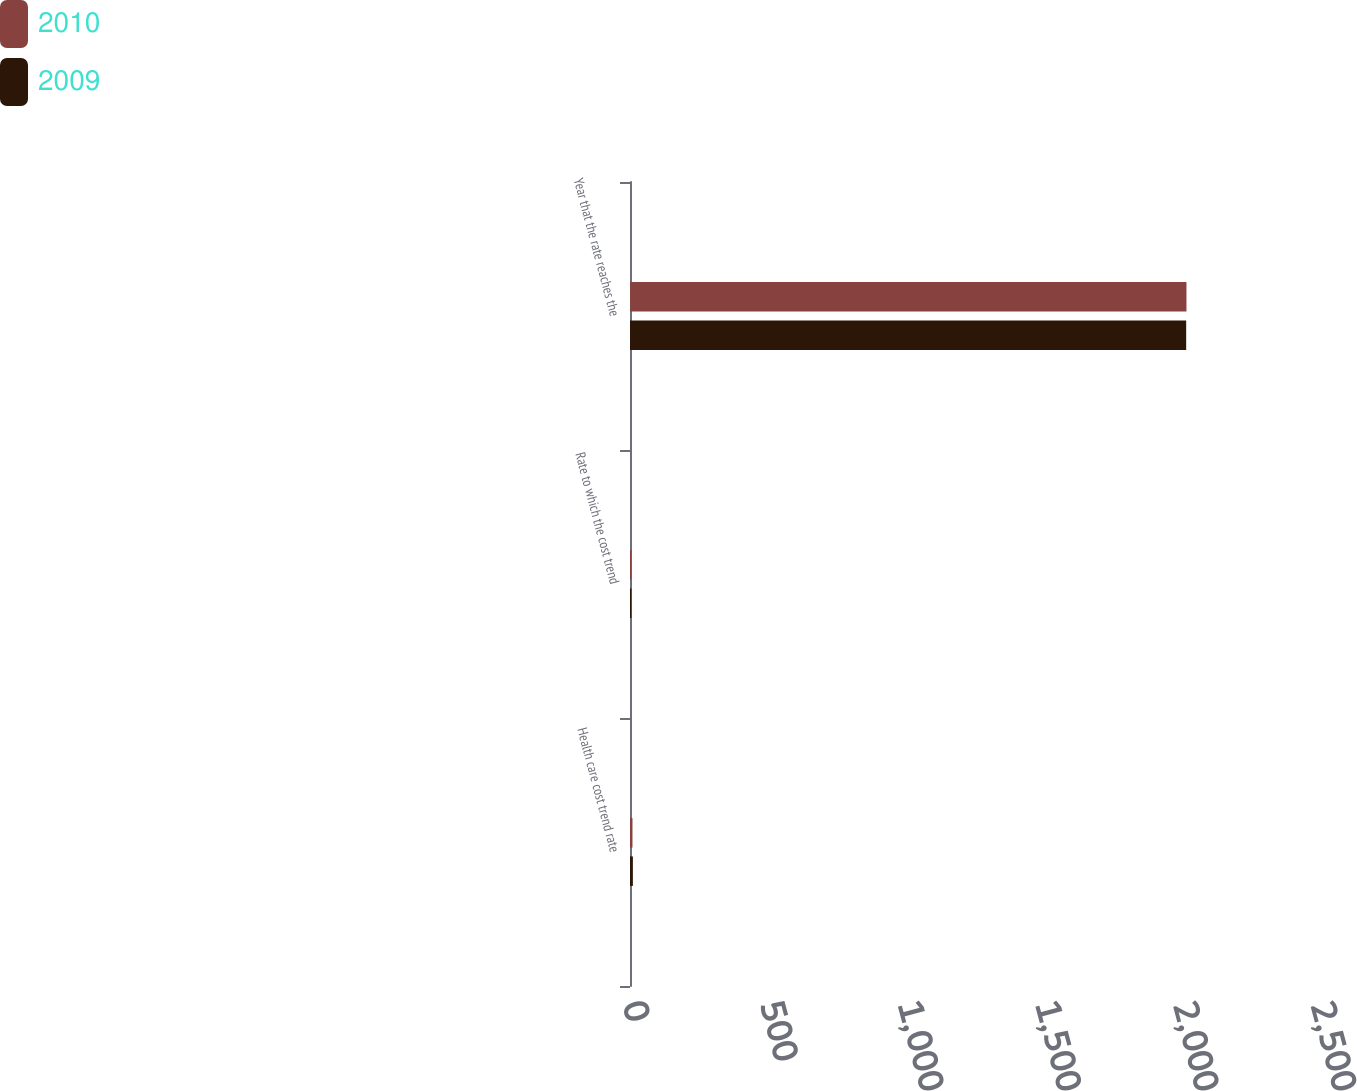Convert chart to OTSL. <chart><loc_0><loc_0><loc_500><loc_500><stacked_bar_chart><ecel><fcel>Health care cost trend rate<fcel>Rate to which the cost trend<fcel>Year that the rate reaches the<nl><fcel>2010<fcel>9<fcel>5<fcel>2022<nl><fcel>2009<fcel>10.5<fcel>5<fcel>2021<nl></chart> 